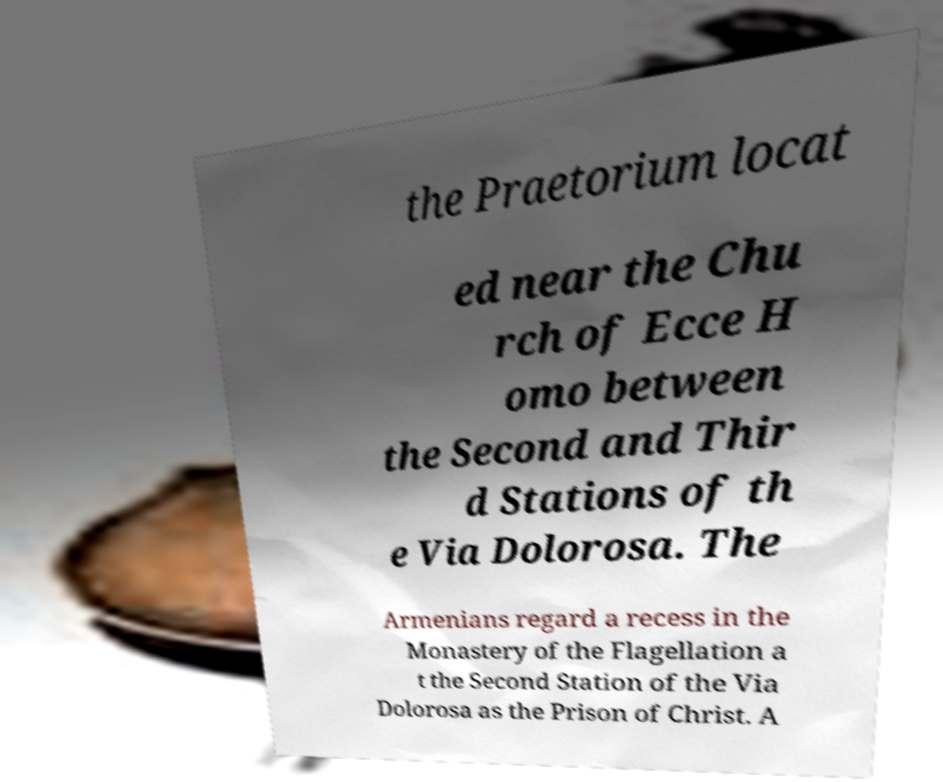Could you extract and type out the text from this image? the Praetorium locat ed near the Chu rch of Ecce H omo between the Second and Thir d Stations of th e Via Dolorosa. The Armenians regard a recess in the Monastery of the Flagellation a t the Second Station of the Via Dolorosa as the Prison of Christ. A 